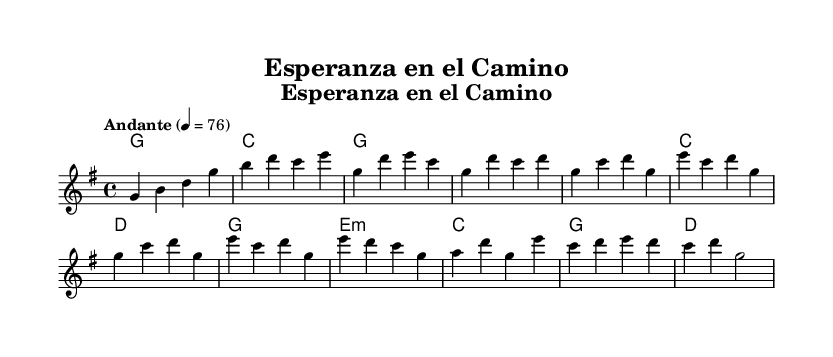What is the key signature of this music? The key signature indicated is G major, which has one sharp (F#).
Answer: G major What is the time signature of this composition? The time signature shown is 4/4, which means there are four beats in each measure.
Answer: 4/4 What is the tempo marking? The tempo marking indicates "Andante," which typically means a moderately slow speed.
Answer: Andante How many measures are in the chorus section? The chorus section consists of four measures, which is determined by counting the grouped sets of notes labeled as the chorus.
Answer: Four What are the primary chords used in the chorus? The primary chords are G, C, and D, as these chords are consistently recurring in the chorus section.
Answer: G, C, D How does the bridge section differ in harmony from the chorus? The bridge features an E minor chord and G major, contrasting with the chorus's use primarily of G, C, and D.
Answer: E minor What mood does the tempo create for this Latin ballad? The Andante tempo contributes to a calming and reflective mood, appropriate for themes of hope and perseverance.
Answer: Calming 